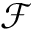<formula> <loc_0><loc_0><loc_500><loc_500>\mathcal { F }</formula> 